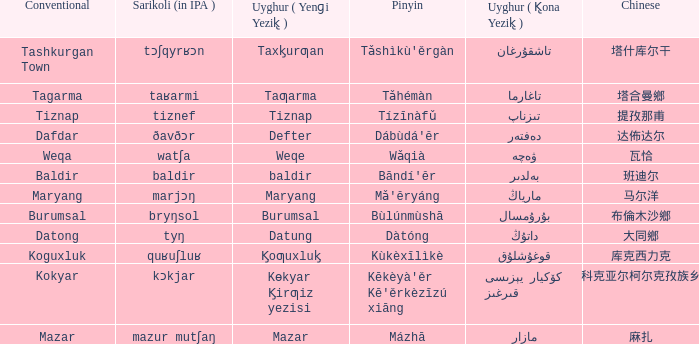Name the conventional for تاغارما Tagarma. 